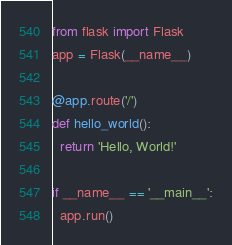Convert code to text. <code><loc_0><loc_0><loc_500><loc_500><_Python_>from flask import Flask
app = Flask(__name__)

@app.route('/')
def hello_world():
  return 'Hello, World!'

if __name__ == '__main__':
  app.run()
</code> 